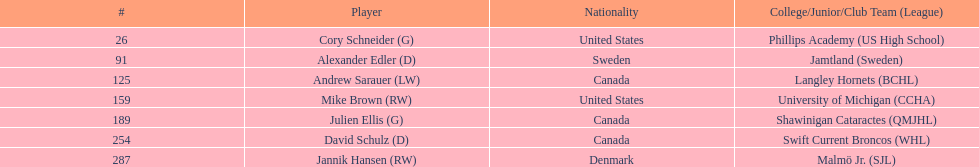Identify the canadian nationality player who was part of the langley hornets. Andrew Sarauer (LW). 